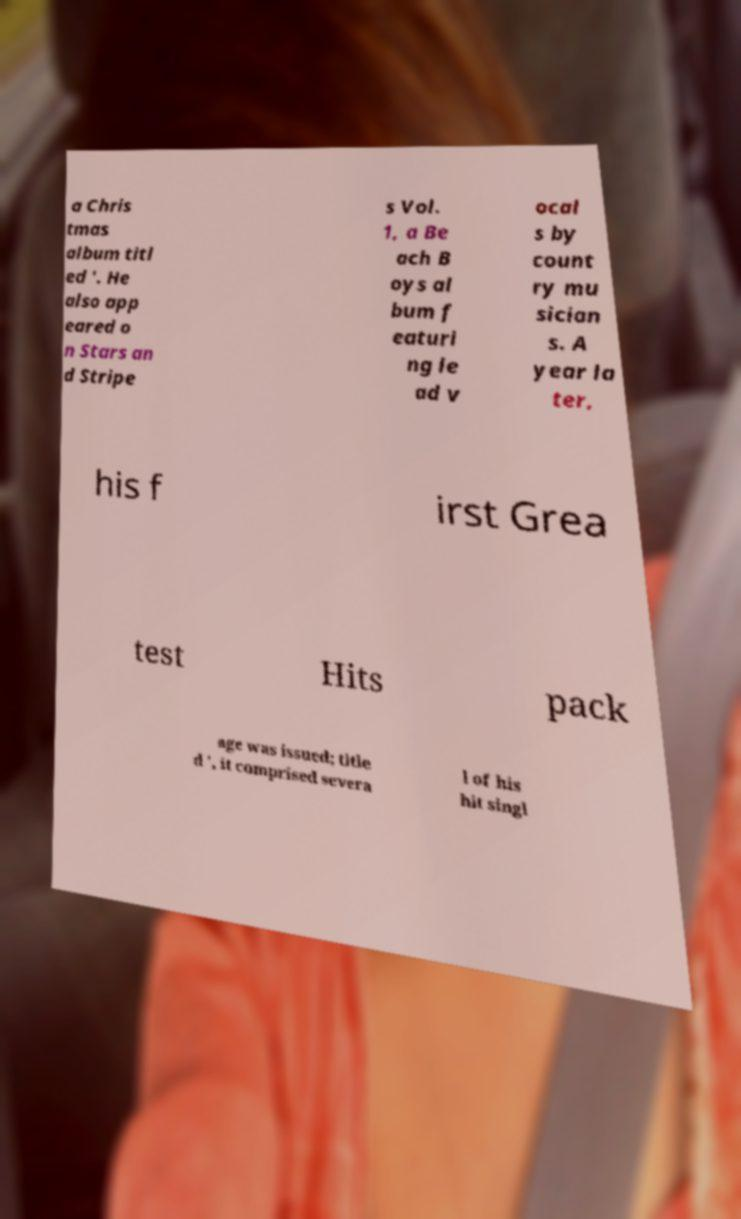Please read and relay the text visible in this image. What does it say? a Chris tmas album titl ed '. He also app eared o n Stars an d Stripe s Vol. 1, a Be ach B oys al bum f eaturi ng le ad v ocal s by count ry mu sician s. A year la ter, his f irst Grea test Hits pack age was issued; title d ', it comprised severa l of his hit singl 